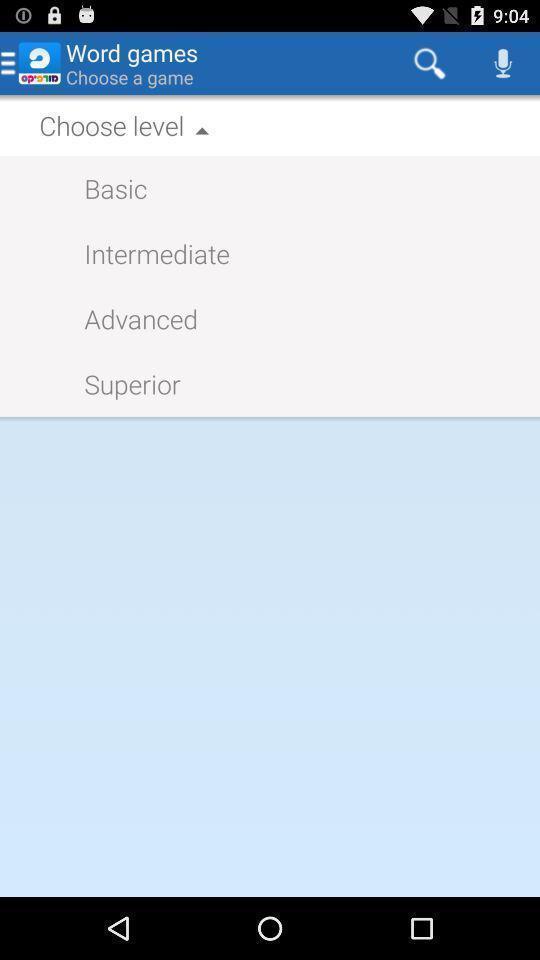Explain the elements present in this screenshot. Search bar of a game showing different levels to choose. 